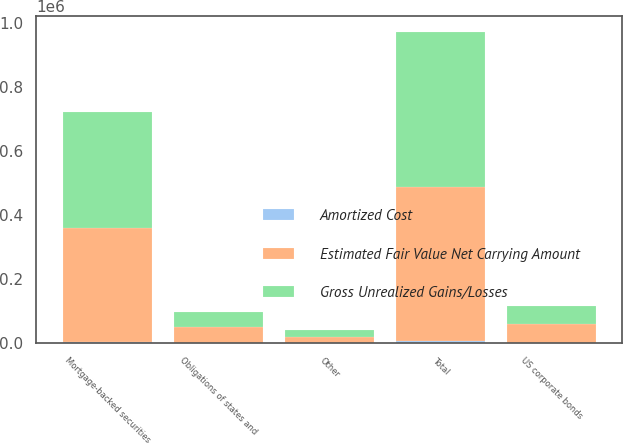Convert chart to OTSL. <chart><loc_0><loc_0><loc_500><loc_500><stacked_bar_chart><ecel><fcel>Mortgage-backed securities<fcel>Obligations of states and<fcel>US corporate bonds<fcel>Other<fcel>Total<nl><fcel>Gross Unrealized Gains/Losses<fcel>359809<fcel>48354<fcel>57926<fcel>19521<fcel>485610<nl><fcel>Amortized Cost<fcel>4071<fcel>193<fcel>429<fcel>41<fcel>4734<nl><fcel>Estimated Fair Value Net Carrying Amount<fcel>355738<fcel>48161<fcel>57497<fcel>19480<fcel>480876<nl></chart> 